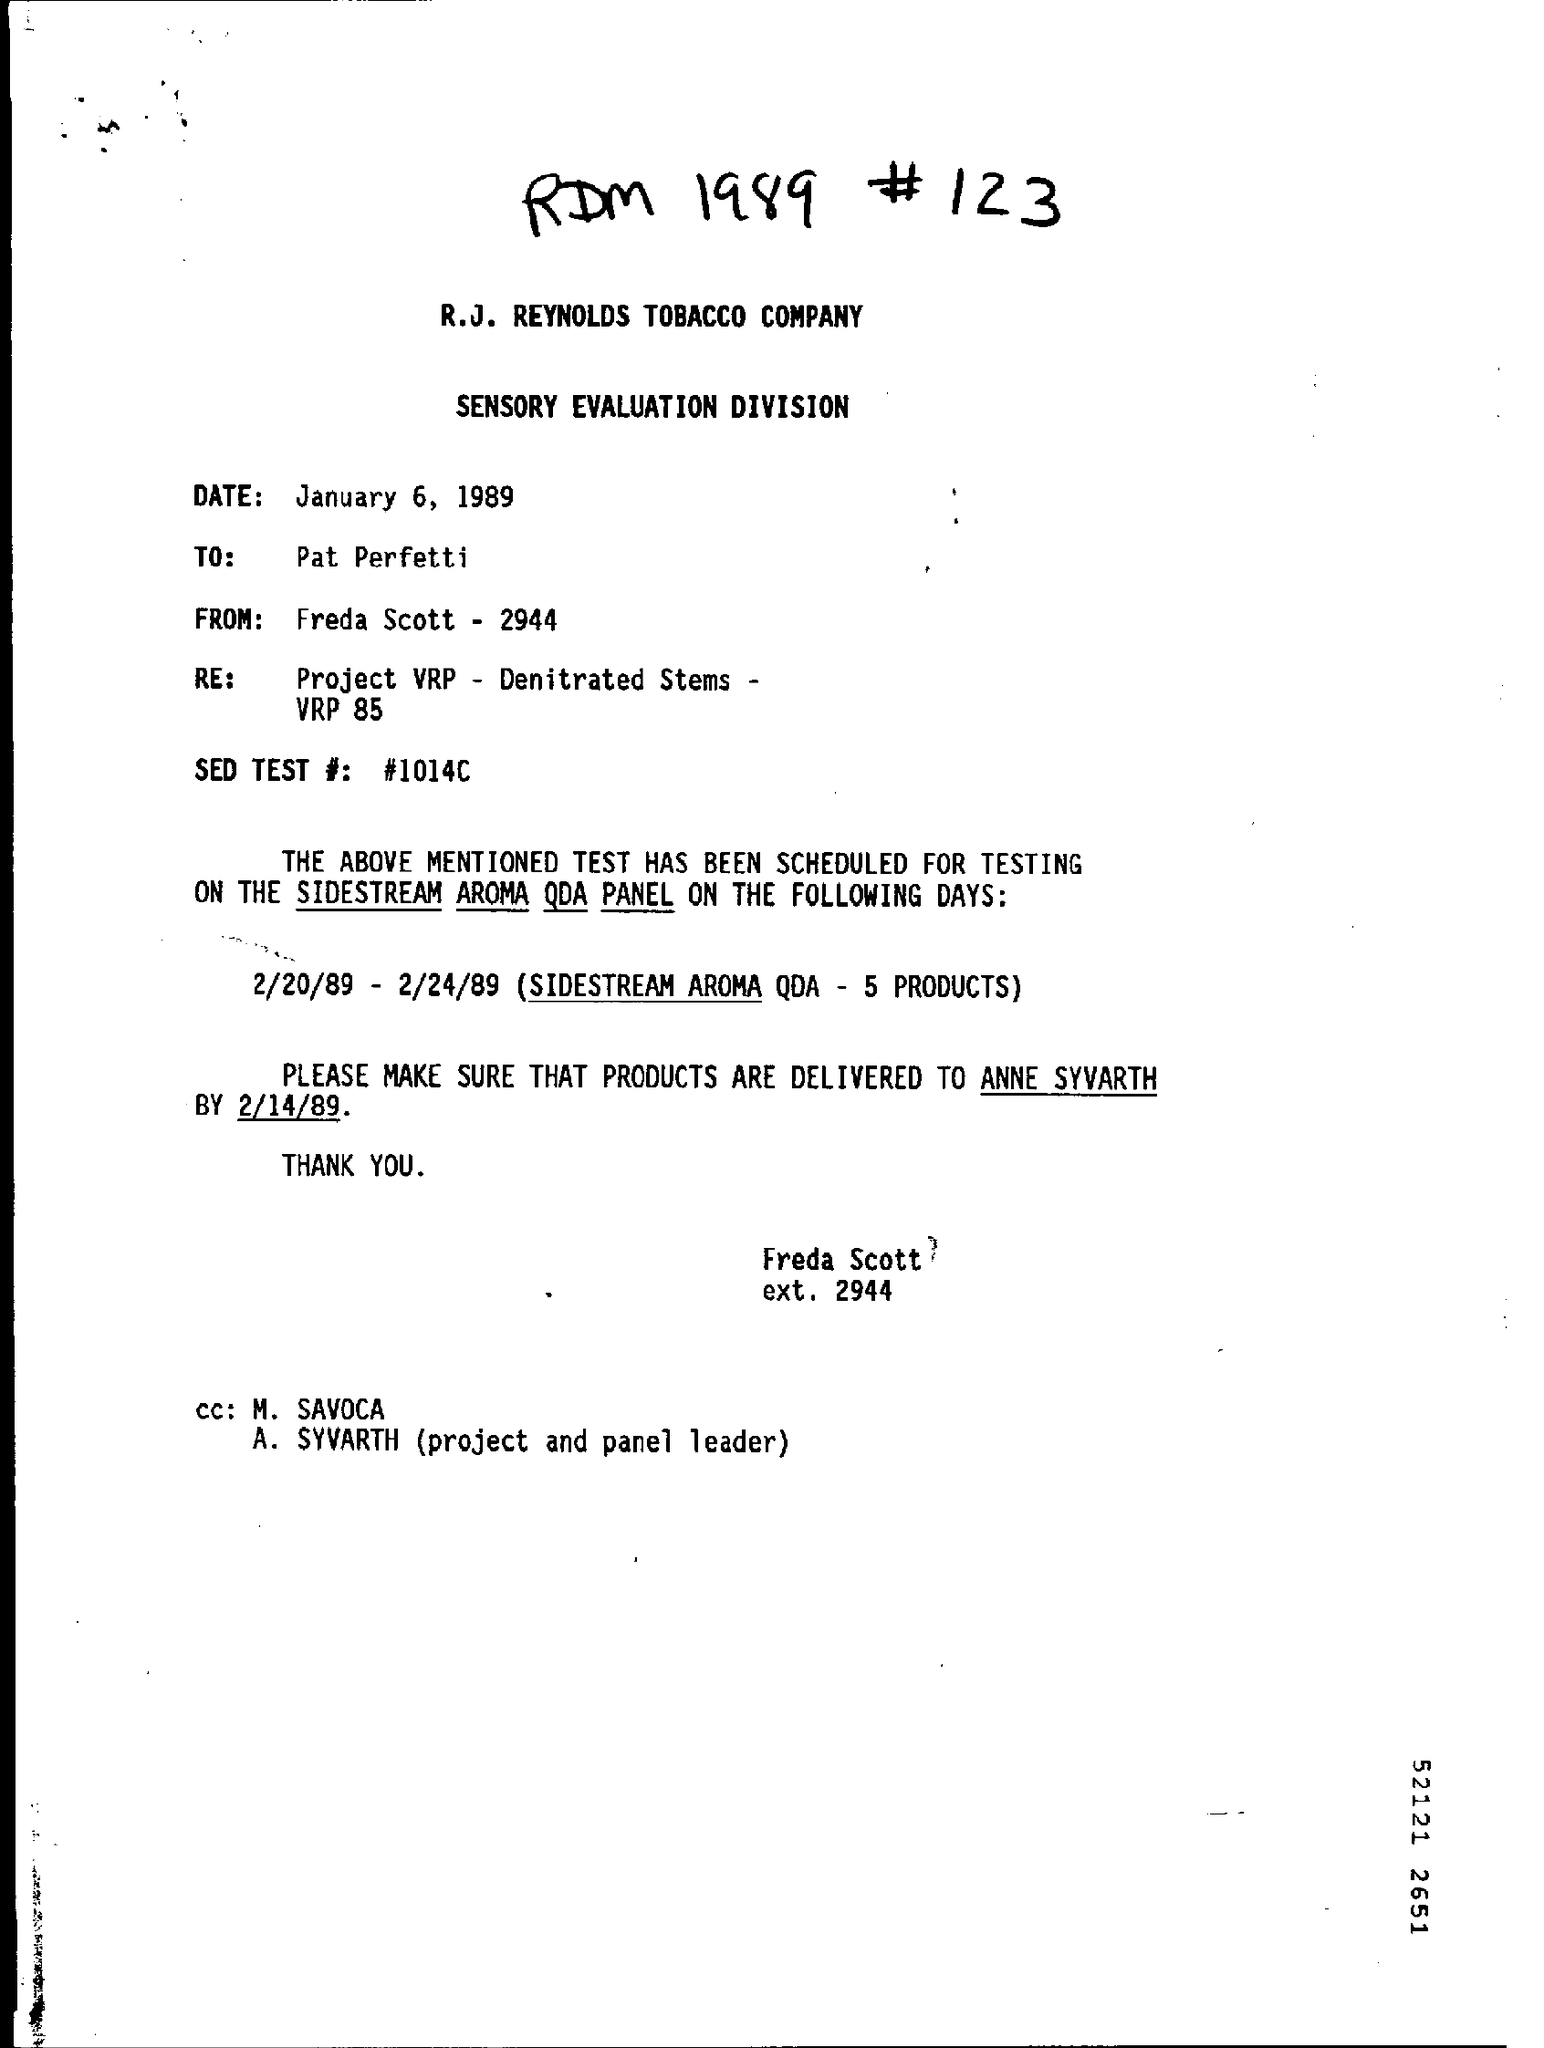What is the date mentioned ?
Give a very brief answer. January 6, 1989. What is mentioned in the re :?
Make the answer very short. Project VRP - Denitrated Stems - VRP 85. What is the sed test # number ?
Make the answer very short. #1014C. 